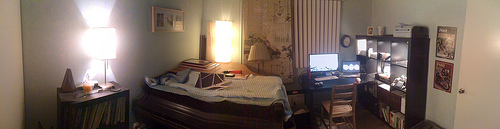Please provide the bounding box coordinate of the region this sentence describes: A white house wall. The exact coordinates for the white wall on the house are slightly broader, capturing more of the wall's edges. A more detailed and closer approximation would be [0.81, 0.35, 0.95, 0.50]. 